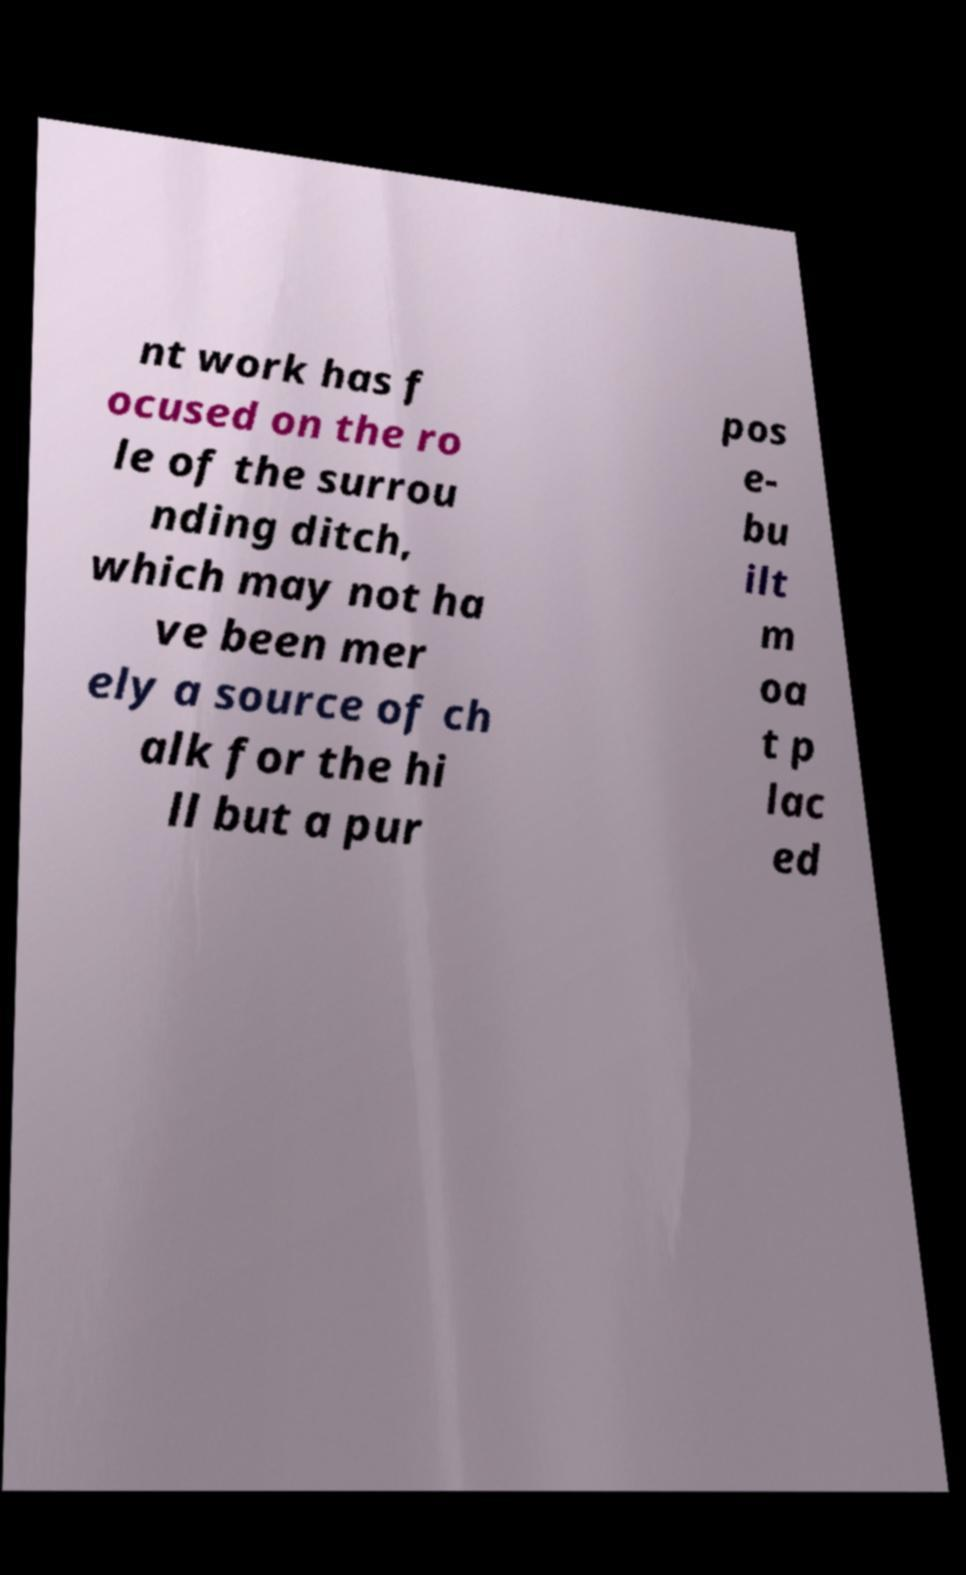There's text embedded in this image that I need extracted. Can you transcribe it verbatim? nt work has f ocused on the ro le of the surrou nding ditch, which may not ha ve been mer ely a source of ch alk for the hi ll but a pur pos e- bu ilt m oa t p lac ed 